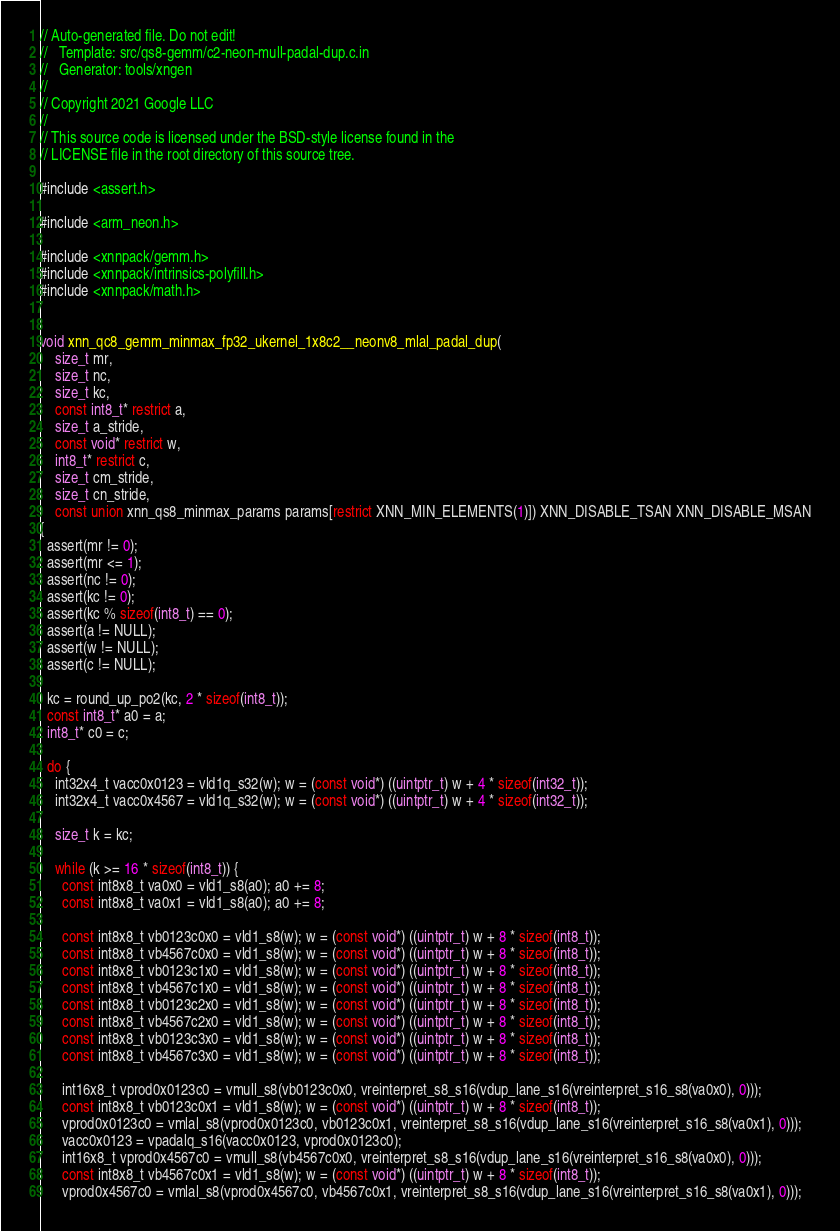Convert code to text. <code><loc_0><loc_0><loc_500><loc_500><_C_>// Auto-generated file. Do not edit!
//   Template: src/qs8-gemm/c2-neon-mull-padal-dup.c.in
//   Generator: tools/xngen
//
// Copyright 2021 Google LLC
//
// This source code is licensed under the BSD-style license found in the
// LICENSE file in the root directory of this source tree.

#include <assert.h>

#include <arm_neon.h>

#include <xnnpack/gemm.h>
#include <xnnpack/intrinsics-polyfill.h>
#include <xnnpack/math.h>


void xnn_qc8_gemm_minmax_fp32_ukernel_1x8c2__neonv8_mlal_padal_dup(
    size_t mr,
    size_t nc,
    size_t kc,
    const int8_t* restrict a,
    size_t a_stride,
    const void* restrict w,
    int8_t* restrict c,
    size_t cm_stride,
    size_t cn_stride,
    const union xnn_qs8_minmax_params params[restrict XNN_MIN_ELEMENTS(1)]) XNN_DISABLE_TSAN XNN_DISABLE_MSAN
{
  assert(mr != 0);
  assert(mr <= 1);
  assert(nc != 0);
  assert(kc != 0);
  assert(kc % sizeof(int8_t) == 0);
  assert(a != NULL);
  assert(w != NULL);
  assert(c != NULL);

  kc = round_up_po2(kc, 2 * sizeof(int8_t));
  const int8_t* a0 = a;
  int8_t* c0 = c;

  do {
    int32x4_t vacc0x0123 = vld1q_s32(w); w = (const void*) ((uintptr_t) w + 4 * sizeof(int32_t));
    int32x4_t vacc0x4567 = vld1q_s32(w); w = (const void*) ((uintptr_t) w + 4 * sizeof(int32_t));

    size_t k = kc;

    while (k >= 16 * sizeof(int8_t)) {
      const int8x8_t va0x0 = vld1_s8(a0); a0 += 8;
      const int8x8_t va0x1 = vld1_s8(a0); a0 += 8;

      const int8x8_t vb0123c0x0 = vld1_s8(w); w = (const void*) ((uintptr_t) w + 8 * sizeof(int8_t));
      const int8x8_t vb4567c0x0 = vld1_s8(w); w = (const void*) ((uintptr_t) w + 8 * sizeof(int8_t));
      const int8x8_t vb0123c1x0 = vld1_s8(w); w = (const void*) ((uintptr_t) w + 8 * sizeof(int8_t));
      const int8x8_t vb4567c1x0 = vld1_s8(w); w = (const void*) ((uintptr_t) w + 8 * sizeof(int8_t));
      const int8x8_t vb0123c2x0 = vld1_s8(w); w = (const void*) ((uintptr_t) w + 8 * sizeof(int8_t));
      const int8x8_t vb4567c2x0 = vld1_s8(w); w = (const void*) ((uintptr_t) w + 8 * sizeof(int8_t));
      const int8x8_t vb0123c3x0 = vld1_s8(w); w = (const void*) ((uintptr_t) w + 8 * sizeof(int8_t));
      const int8x8_t vb4567c3x0 = vld1_s8(w); w = (const void*) ((uintptr_t) w + 8 * sizeof(int8_t));

      int16x8_t vprod0x0123c0 = vmull_s8(vb0123c0x0, vreinterpret_s8_s16(vdup_lane_s16(vreinterpret_s16_s8(va0x0), 0)));
      const int8x8_t vb0123c0x1 = vld1_s8(w); w = (const void*) ((uintptr_t) w + 8 * sizeof(int8_t));
      vprod0x0123c0 = vmlal_s8(vprod0x0123c0, vb0123c0x1, vreinterpret_s8_s16(vdup_lane_s16(vreinterpret_s16_s8(va0x1), 0)));
      vacc0x0123 = vpadalq_s16(vacc0x0123, vprod0x0123c0);
      int16x8_t vprod0x4567c0 = vmull_s8(vb4567c0x0, vreinterpret_s8_s16(vdup_lane_s16(vreinterpret_s16_s8(va0x0), 0)));
      const int8x8_t vb4567c0x1 = vld1_s8(w); w = (const void*) ((uintptr_t) w + 8 * sizeof(int8_t));
      vprod0x4567c0 = vmlal_s8(vprod0x4567c0, vb4567c0x1, vreinterpret_s8_s16(vdup_lane_s16(vreinterpret_s16_s8(va0x1), 0)));</code> 